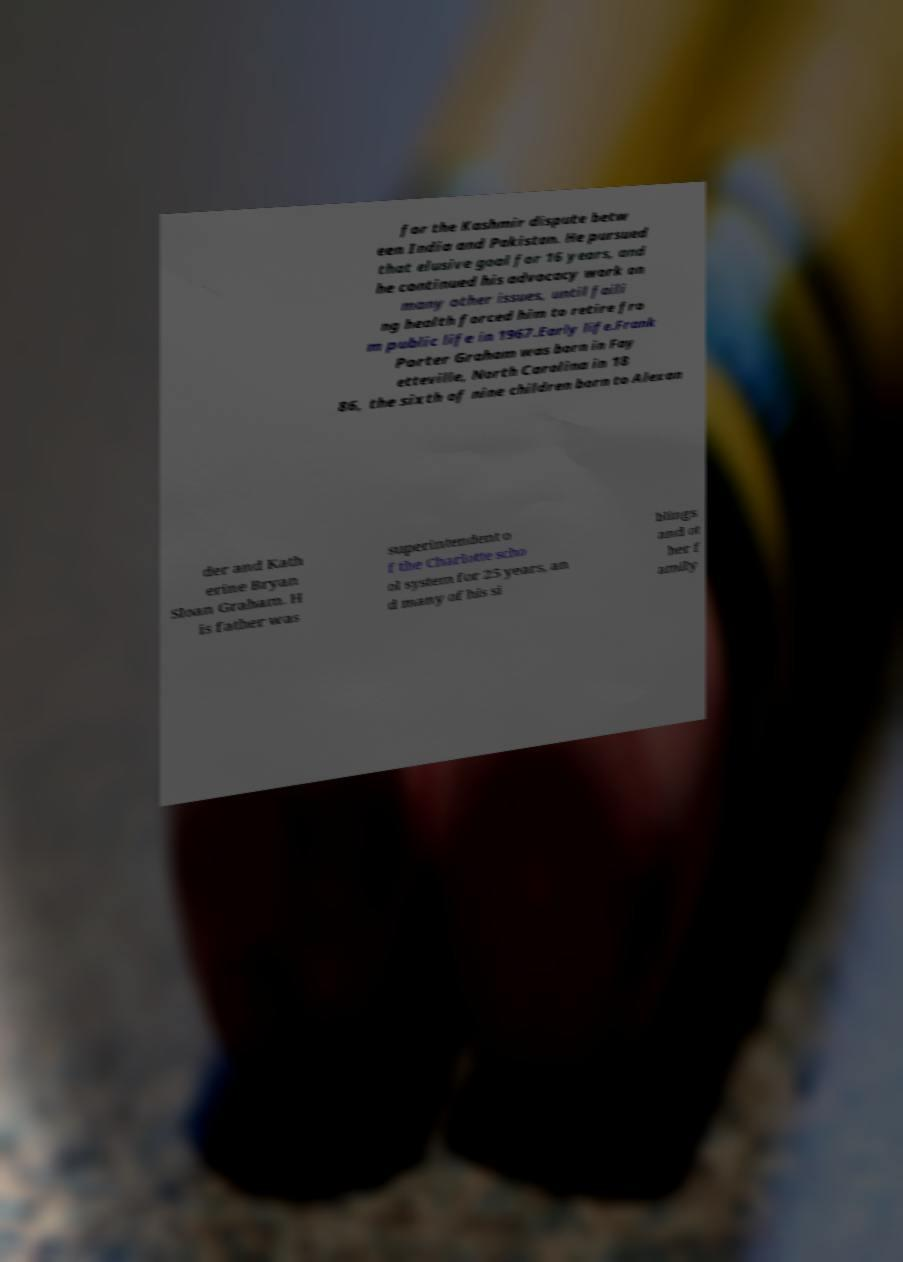Could you extract and type out the text from this image? for the Kashmir dispute betw een India and Pakistan. He pursued that elusive goal for 16 years, and he continued his advocacy work on many other issues, until faili ng health forced him to retire fro m public life in 1967.Early life.Frank Porter Graham was born in Fay etteville, North Carolina in 18 86, the sixth of nine children born to Alexan der and Kath erine Bryan Sloan Graham. H is father was superintendent o f the Charlotte scho ol system for 25 years, an d many of his si blings and ot her f amily 